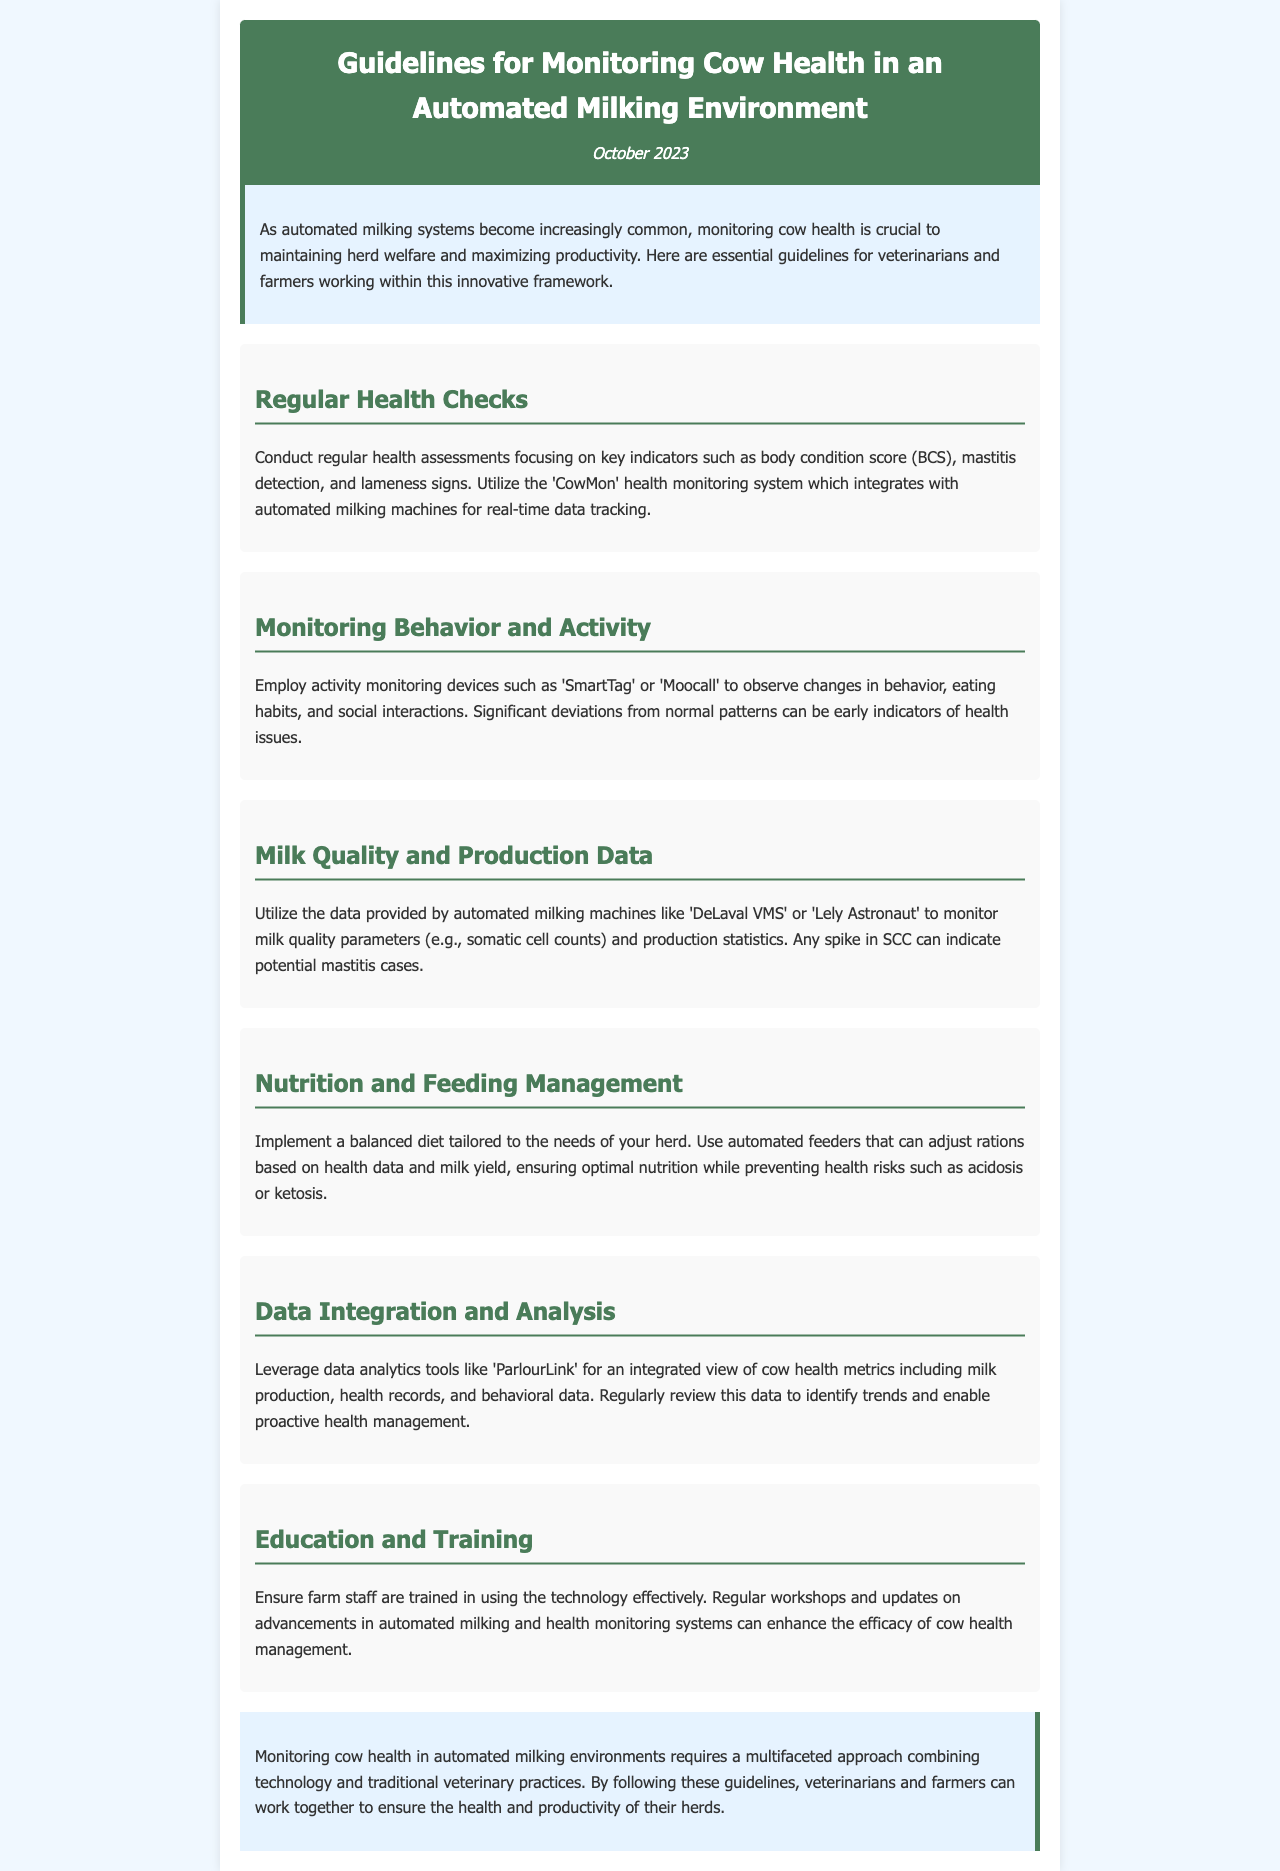What is the title of the newsletter? The title of the newsletter is presented in the header, introducing the main theme of the document.
Answer: Guidelines for Monitoring Cow Health in an Automated Milking Environment What is the publication date? The publication date is mentioned below the title and indicates when the newsletter was released.
Answer: October 2023 Which system is recommended for health assessments? The document specifies a monitoring system that integrates with automated milking machines to track health data.
Answer: CowMon What type of devices can be used to monitor behavior? The document lists specific activity monitoring devices that help observe cow behavior.
Answer: SmartTag or Moocall What is a key indicator for detecting mastitis? The document highlights an important quality parameter that indicates potential health issues such as mastitis.
Answer: Somatic cell counts How can nutrition be managed in automated milking systems? The document recommends the use of equipment to ensure proper nutrition tailored for the herd.
Answer: Automated feeders What is a suggested tool for data analytics in cow health? The document advises on a specific tool that helps analyze cow health metrics.
Answer: ParlourLink What is a critical aspect of staff development mentioned? The document emphasizes ongoing education for farm personnel regarding technology use.
Answer: Training 